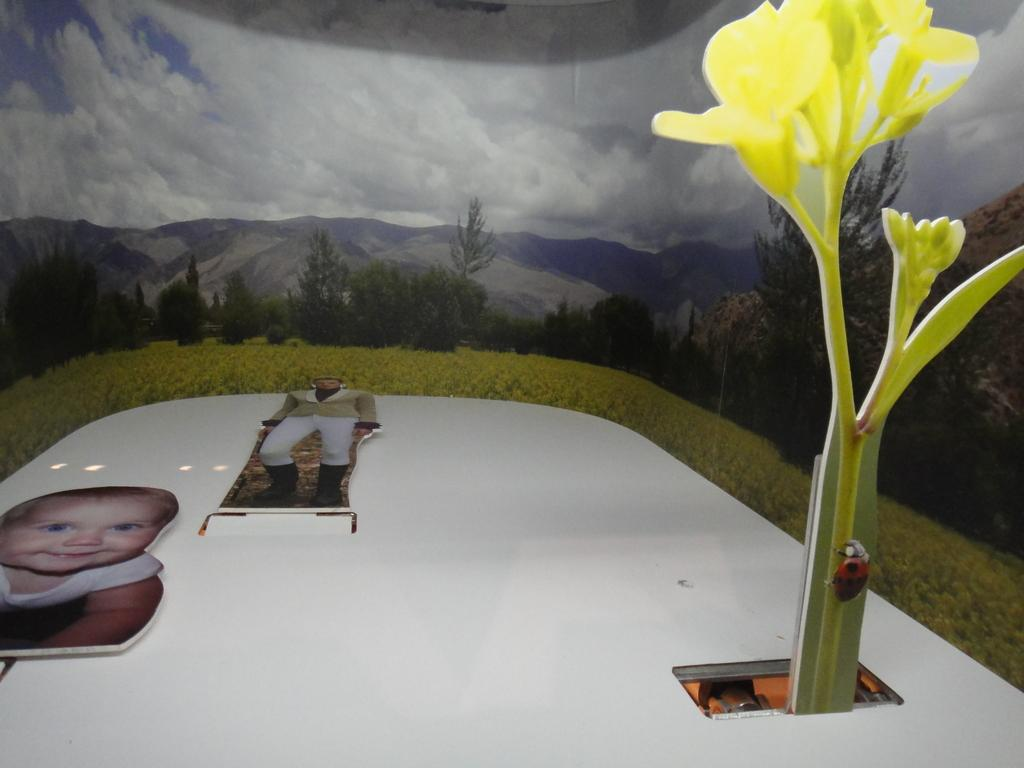What type of furniture is present in the image? There is a table in the image. What objects can be seen on the table? There are objects on the table that resemble boards. What can be seen in the background of the image? There is a wall poster visible in the background of the image. What type of star is visible in the image? There is no star visible in the image. What is the source of the flame in the image? There is no flame present in the image. 